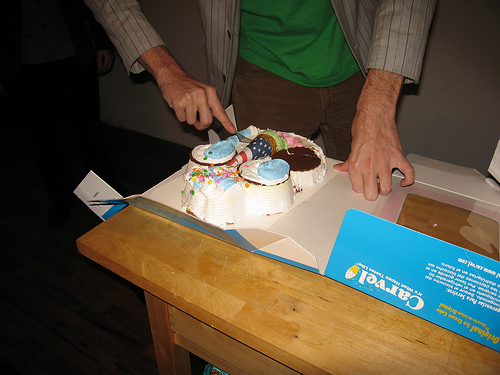How many people are in the picture? 1 